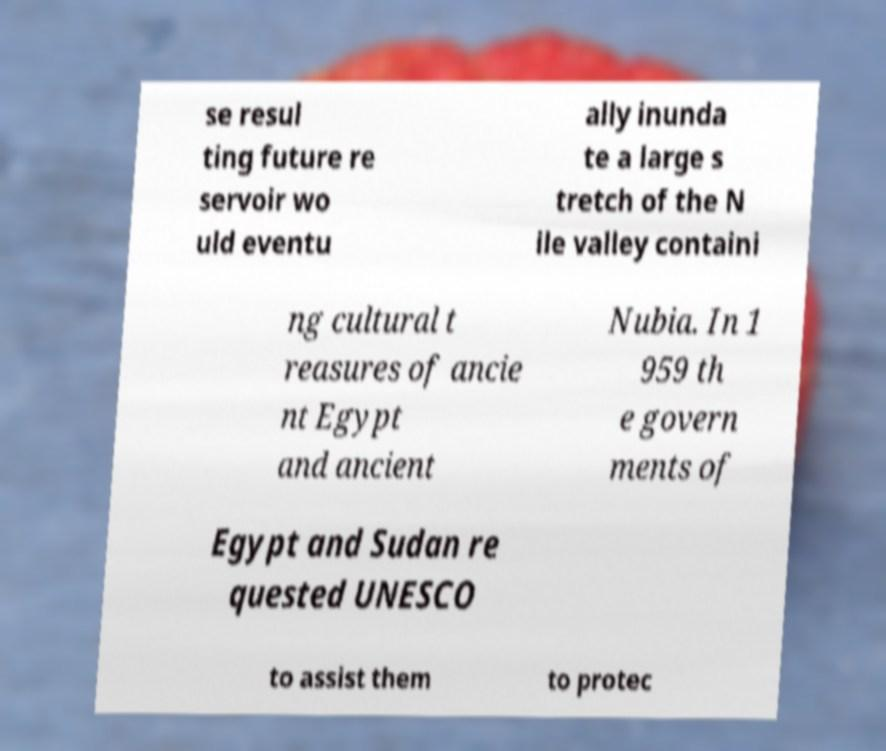I need the written content from this picture converted into text. Can you do that? se resul ting future re servoir wo uld eventu ally inunda te a large s tretch of the N ile valley containi ng cultural t reasures of ancie nt Egypt and ancient Nubia. In 1 959 th e govern ments of Egypt and Sudan re quested UNESCO to assist them to protec 